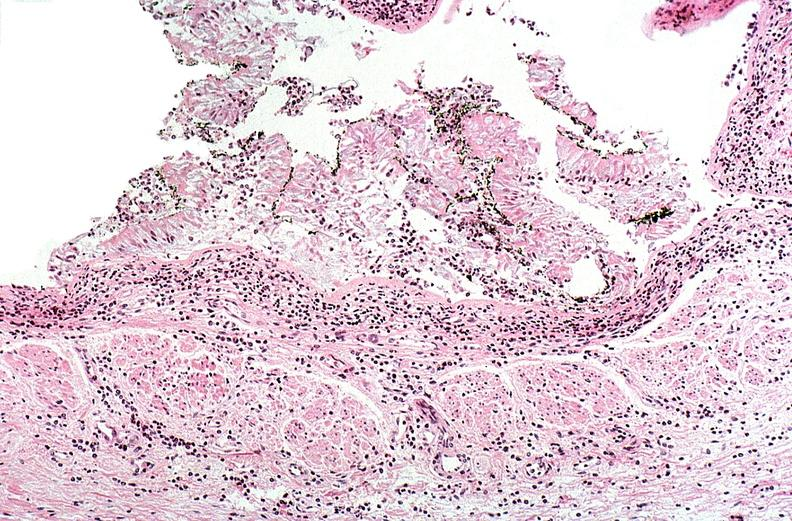what burn?
Answer the question using a single word or phrase. Thermal 